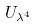<formula> <loc_0><loc_0><loc_500><loc_500>U _ { \lambda ^ { 4 } }</formula> 